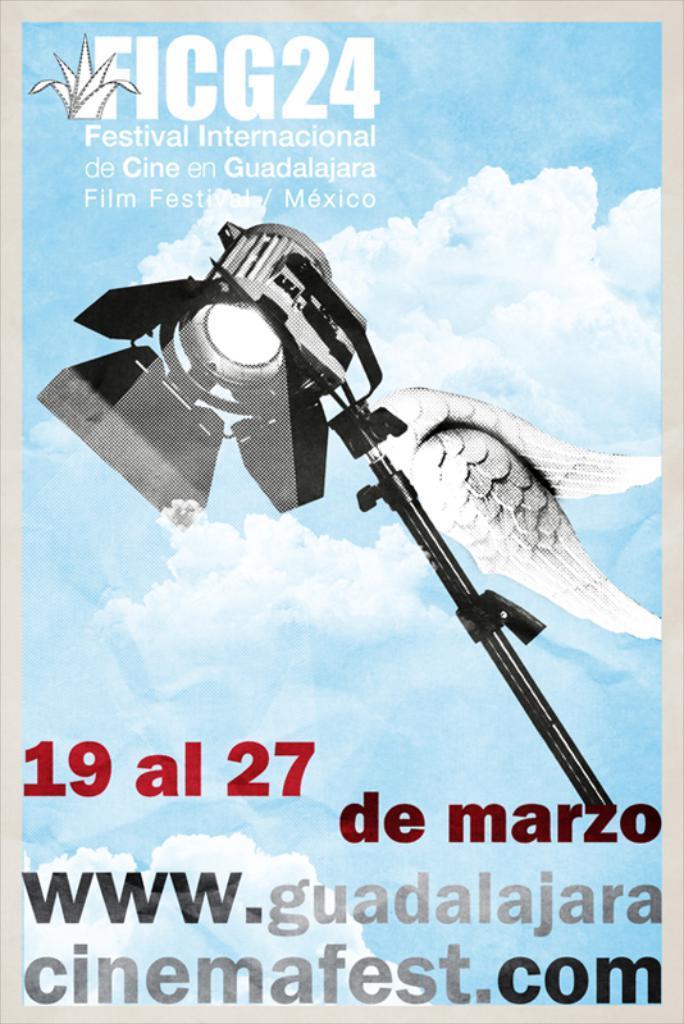What can be seen in the image? There is a poster in the image. What is written on the poster? The poster has text written on it. What type of wilderness can be seen through the door in the image? There is no door present in the image, and therefore no wilderness can be seen through it. 